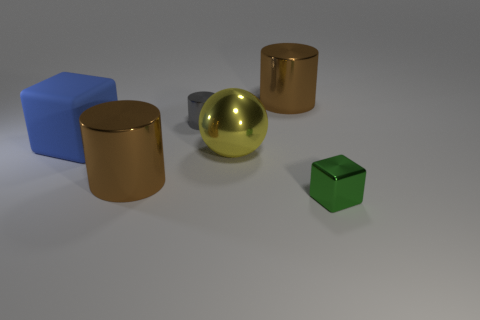Are there any other things that have the same material as the large cube?
Keep it short and to the point. No. Is the color of the big metal thing that is behind the big matte cube the same as the metallic cube?
Your answer should be compact. No. Is the number of yellow spheres less than the number of big brown shiny cylinders?
Your answer should be compact. Yes. What number of other objects are there of the same color as the tiny block?
Your response must be concise. 0. Is the material of the cube left of the tiny green metallic thing the same as the small block?
Your response must be concise. No. What material is the small thing that is left of the tiny cube?
Provide a succinct answer. Metal. What size is the brown thing that is right of the tiny object left of the green object?
Your answer should be compact. Large. Is there a tiny gray thing made of the same material as the green object?
Offer a terse response. Yes. There is a big brown object that is to the left of the large metal cylinder on the right side of the cylinder that is in front of the tiny gray metallic object; what is its shape?
Your answer should be compact. Cylinder. Does the block that is behind the yellow metallic object have the same color as the tiny metal thing that is on the left side of the small green shiny cube?
Your answer should be very brief. No. 